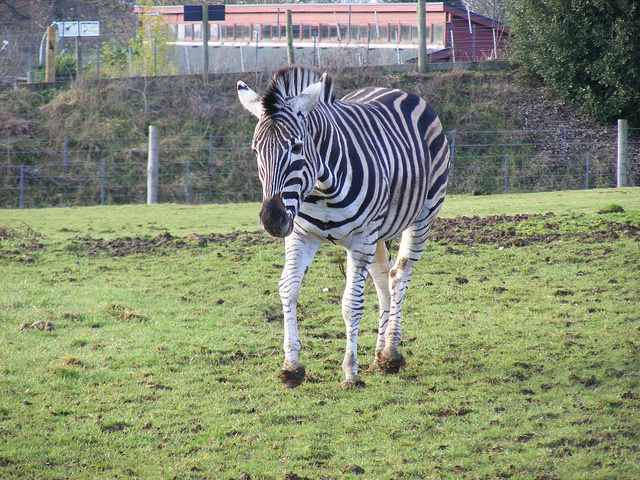Describe the objects in this image and their specific colors. I can see a zebra in gray, darkgray, navy, and lightgray tones in this image. 